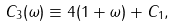Convert formula to latex. <formula><loc_0><loc_0><loc_500><loc_500>C _ { 3 } ( \omega ) \equiv 4 ( 1 + \omega ) + C _ { 1 } ,</formula> 